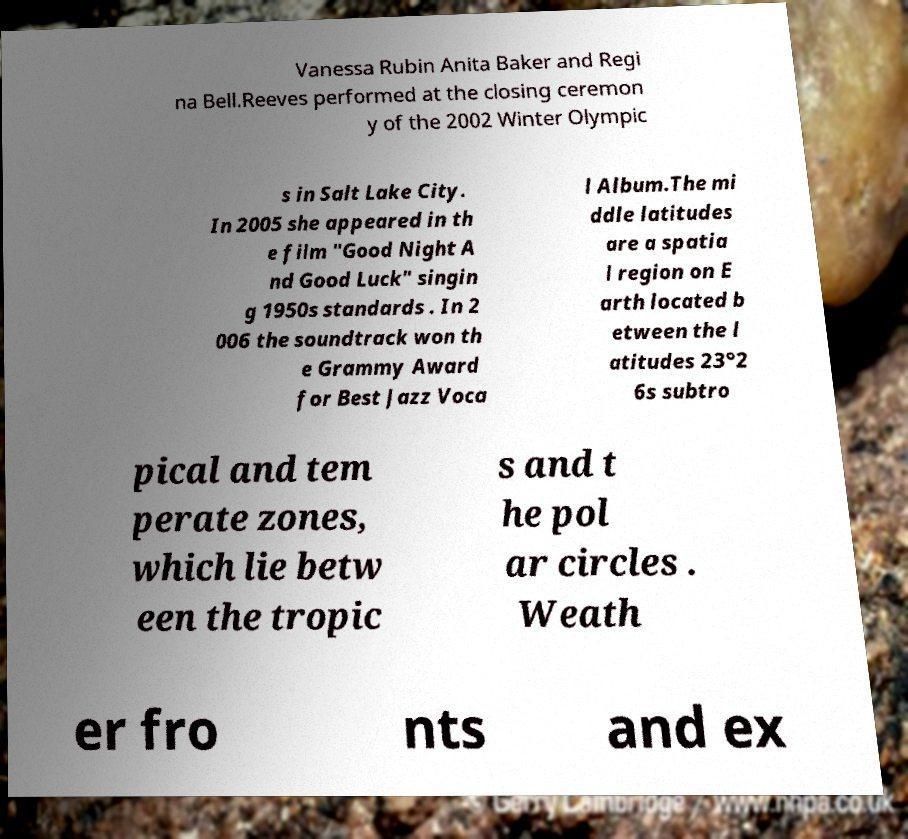There's text embedded in this image that I need extracted. Can you transcribe it verbatim? Vanessa Rubin Anita Baker and Regi na Bell.Reeves performed at the closing ceremon y of the 2002 Winter Olympic s in Salt Lake City. In 2005 she appeared in th e film "Good Night A nd Good Luck" singin g 1950s standards . In 2 006 the soundtrack won th e Grammy Award for Best Jazz Voca l Album.The mi ddle latitudes are a spatia l region on E arth located b etween the l atitudes 23°2 6s subtro pical and tem perate zones, which lie betw een the tropic s and t he pol ar circles . Weath er fro nts and ex 